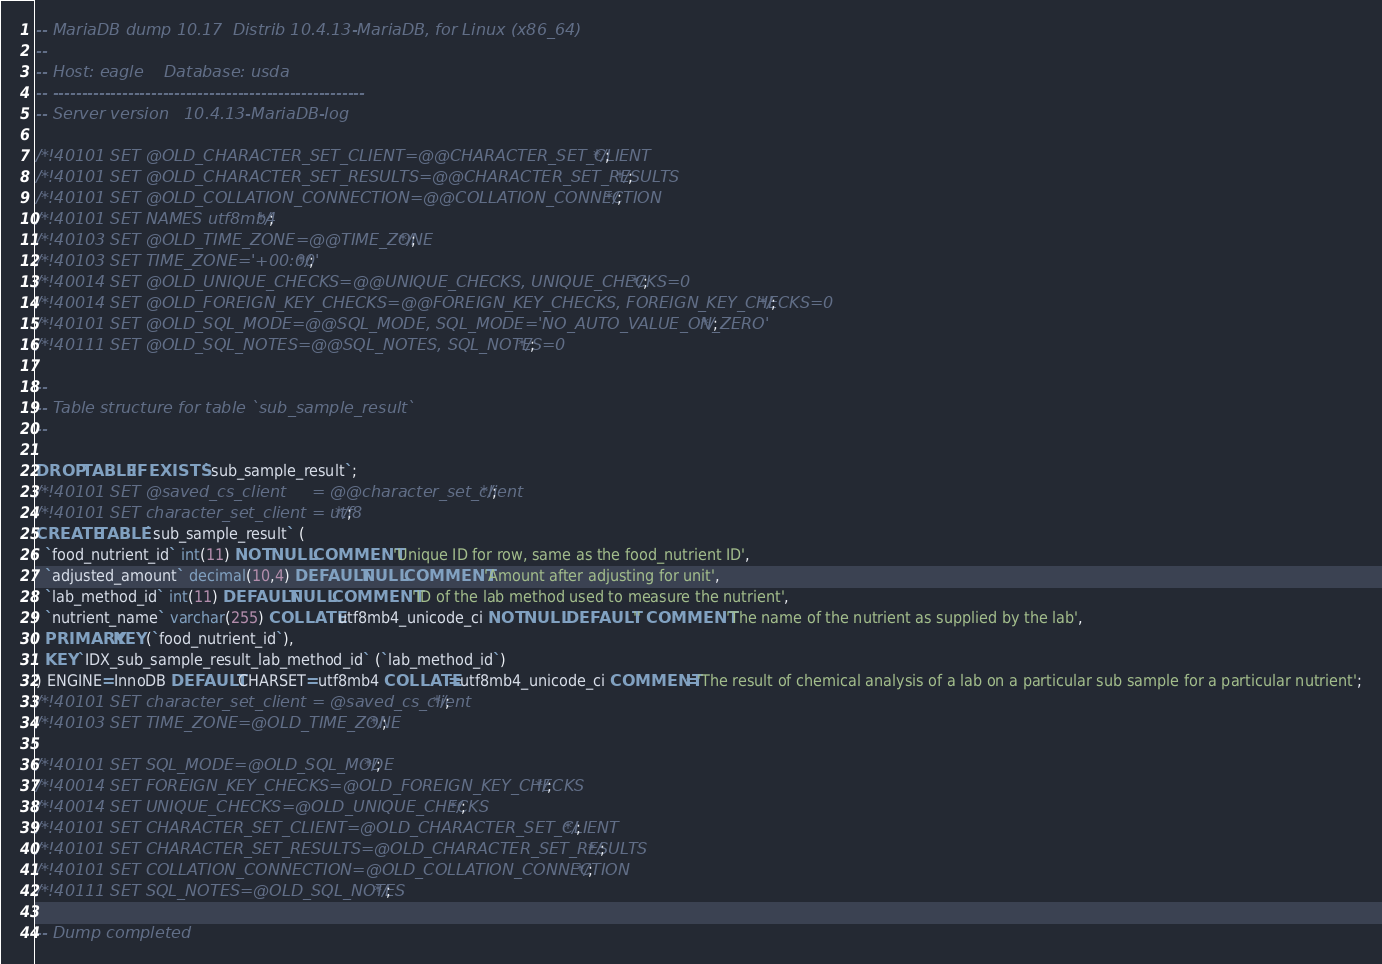Convert code to text. <code><loc_0><loc_0><loc_500><loc_500><_SQL_>-- MariaDB dump 10.17  Distrib 10.4.13-MariaDB, for Linux (x86_64)
--
-- Host: eagle    Database: usda
-- ------------------------------------------------------
-- Server version	10.4.13-MariaDB-log

/*!40101 SET @OLD_CHARACTER_SET_CLIENT=@@CHARACTER_SET_CLIENT */;
/*!40101 SET @OLD_CHARACTER_SET_RESULTS=@@CHARACTER_SET_RESULTS */;
/*!40101 SET @OLD_COLLATION_CONNECTION=@@COLLATION_CONNECTION */;
/*!40101 SET NAMES utf8mb4 */;
/*!40103 SET @OLD_TIME_ZONE=@@TIME_ZONE */;
/*!40103 SET TIME_ZONE='+00:00' */;
/*!40014 SET @OLD_UNIQUE_CHECKS=@@UNIQUE_CHECKS, UNIQUE_CHECKS=0 */;
/*!40014 SET @OLD_FOREIGN_KEY_CHECKS=@@FOREIGN_KEY_CHECKS, FOREIGN_KEY_CHECKS=0 */;
/*!40101 SET @OLD_SQL_MODE=@@SQL_MODE, SQL_MODE='NO_AUTO_VALUE_ON_ZERO' */;
/*!40111 SET @OLD_SQL_NOTES=@@SQL_NOTES, SQL_NOTES=0 */;

--
-- Table structure for table `sub_sample_result`
--

DROP TABLE IF EXISTS `sub_sample_result`;
/*!40101 SET @saved_cs_client     = @@character_set_client */;
/*!40101 SET character_set_client = utf8 */;
CREATE TABLE `sub_sample_result` (
  `food_nutrient_id` int(11) NOT NULL COMMENT 'Unique ID for row, same as the food_nutrient ID',
  `adjusted_amount` decimal(10,4) DEFAULT NULL COMMENT 'Amount after adjusting for unit',
  `lab_method_id` int(11) DEFAULT NULL COMMENT 'ID of the lab method used to measure the nutrient',
  `nutrient_name` varchar(255) COLLATE utf8mb4_unicode_ci NOT NULL DEFAULT '' COMMENT 'The name of the nutrient as supplied by the lab',
  PRIMARY KEY (`food_nutrient_id`),
  KEY `IDX_sub_sample_result_lab_method_id` (`lab_method_id`)
) ENGINE=InnoDB DEFAULT CHARSET=utf8mb4 COLLATE=utf8mb4_unicode_ci COMMENT='The result of chemical analysis of a lab on a particular sub sample for a particular nutrient';
/*!40101 SET character_set_client = @saved_cs_client */;
/*!40103 SET TIME_ZONE=@OLD_TIME_ZONE */;

/*!40101 SET SQL_MODE=@OLD_SQL_MODE */;
/*!40014 SET FOREIGN_KEY_CHECKS=@OLD_FOREIGN_KEY_CHECKS */;
/*!40014 SET UNIQUE_CHECKS=@OLD_UNIQUE_CHECKS */;
/*!40101 SET CHARACTER_SET_CLIENT=@OLD_CHARACTER_SET_CLIENT */;
/*!40101 SET CHARACTER_SET_RESULTS=@OLD_CHARACTER_SET_RESULTS */;
/*!40101 SET COLLATION_CONNECTION=@OLD_COLLATION_CONNECTION */;
/*!40111 SET SQL_NOTES=@OLD_SQL_NOTES */;

-- Dump completed
</code> 